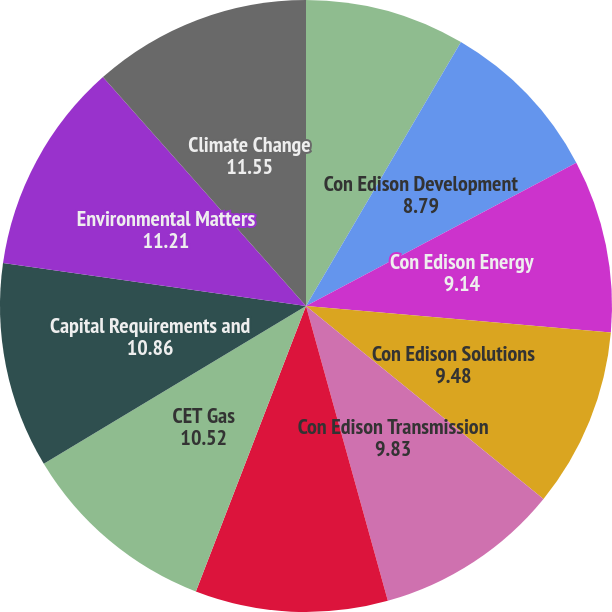<chart> <loc_0><loc_0><loc_500><loc_500><pie_chart><fcel>Clean Energy Businesses<fcel>Con Edison Development<fcel>Con Edison Energy<fcel>Con Edison Solutions<fcel>Con Edison Transmission<fcel>CET Electric<fcel>CET Gas<fcel>Capital Requirements and<fcel>Environmental Matters<fcel>Climate Change<nl><fcel>8.45%<fcel>8.79%<fcel>9.14%<fcel>9.48%<fcel>9.83%<fcel>10.17%<fcel>10.52%<fcel>10.86%<fcel>11.21%<fcel>11.55%<nl></chart> 